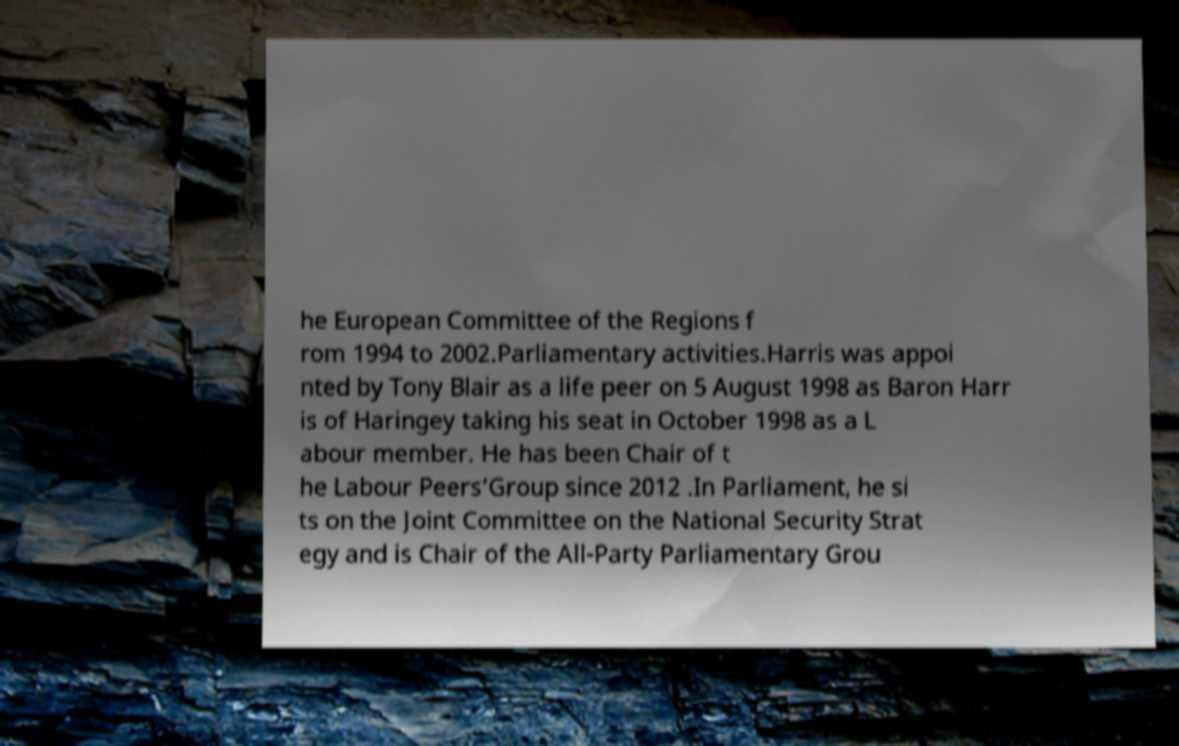Can you read and provide the text displayed in the image?This photo seems to have some interesting text. Can you extract and type it out for me? he European Committee of the Regions f rom 1994 to 2002.Parliamentary activities.Harris was appoi nted by Tony Blair as a life peer on 5 August 1998 as Baron Harr is of Haringey taking his seat in October 1998 as a L abour member. He has been Chair of t he Labour Peers’Group since 2012 .In Parliament, he si ts on the Joint Committee on the National Security Strat egy and is Chair of the All-Party Parliamentary Grou 